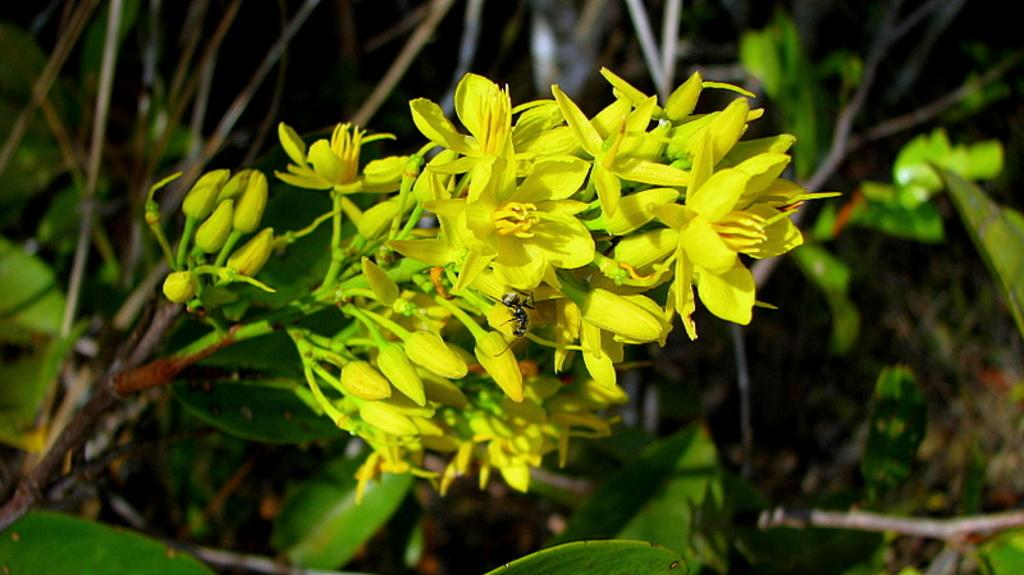What color are the flowers in the image? The flowers in the image are yellow. What other parts of the plants can be seen in the image? There are yellow buds, green leaves, and green stems in the image. Can you describe the overall quality of the image? The image is slightly blurry. How does the bulb in the image change its color? There is no bulb present in the image; it features yellow flowers, yellow buds, green leaves, and green stems. What type of care do the flowers in the image require? The image does not provide information about the care required for the flowers; it only shows their appearance. 